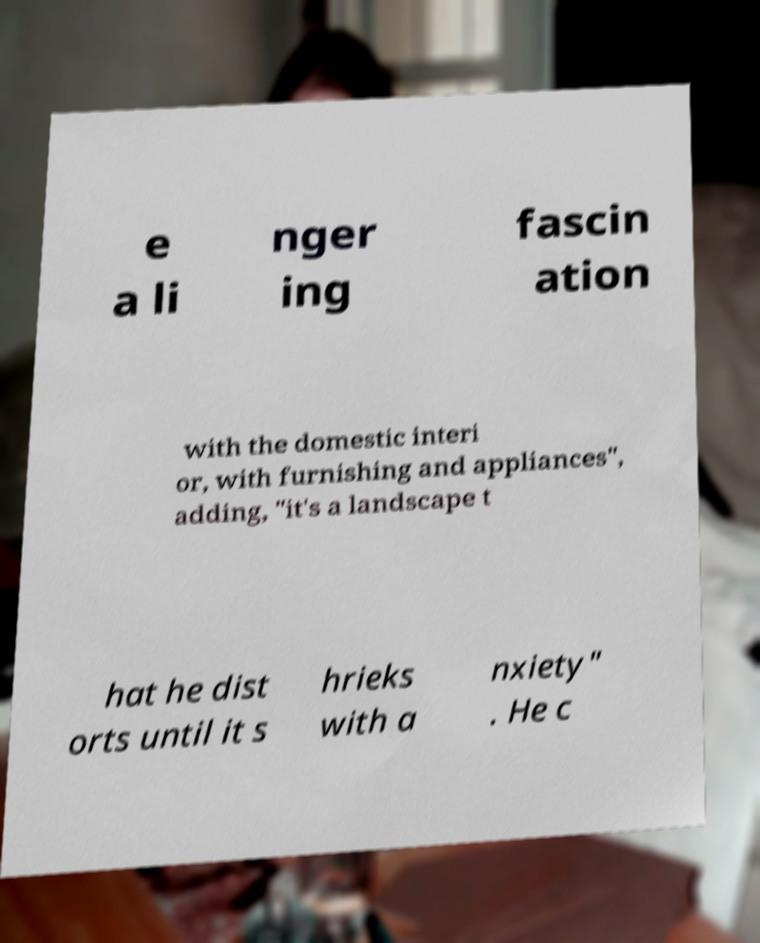Could you extract and type out the text from this image? e a li nger ing fascin ation with the domestic interi or, with furnishing and appliances", adding, "it's a landscape t hat he dist orts until it s hrieks with a nxiety" . He c 